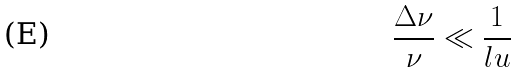Convert formula to latex. <formula><loc_0><loc_0><loc_500><loc_500>\frac { \Delta \nu } { \nu } \ll \frac { 1 } { l u }</formula> 